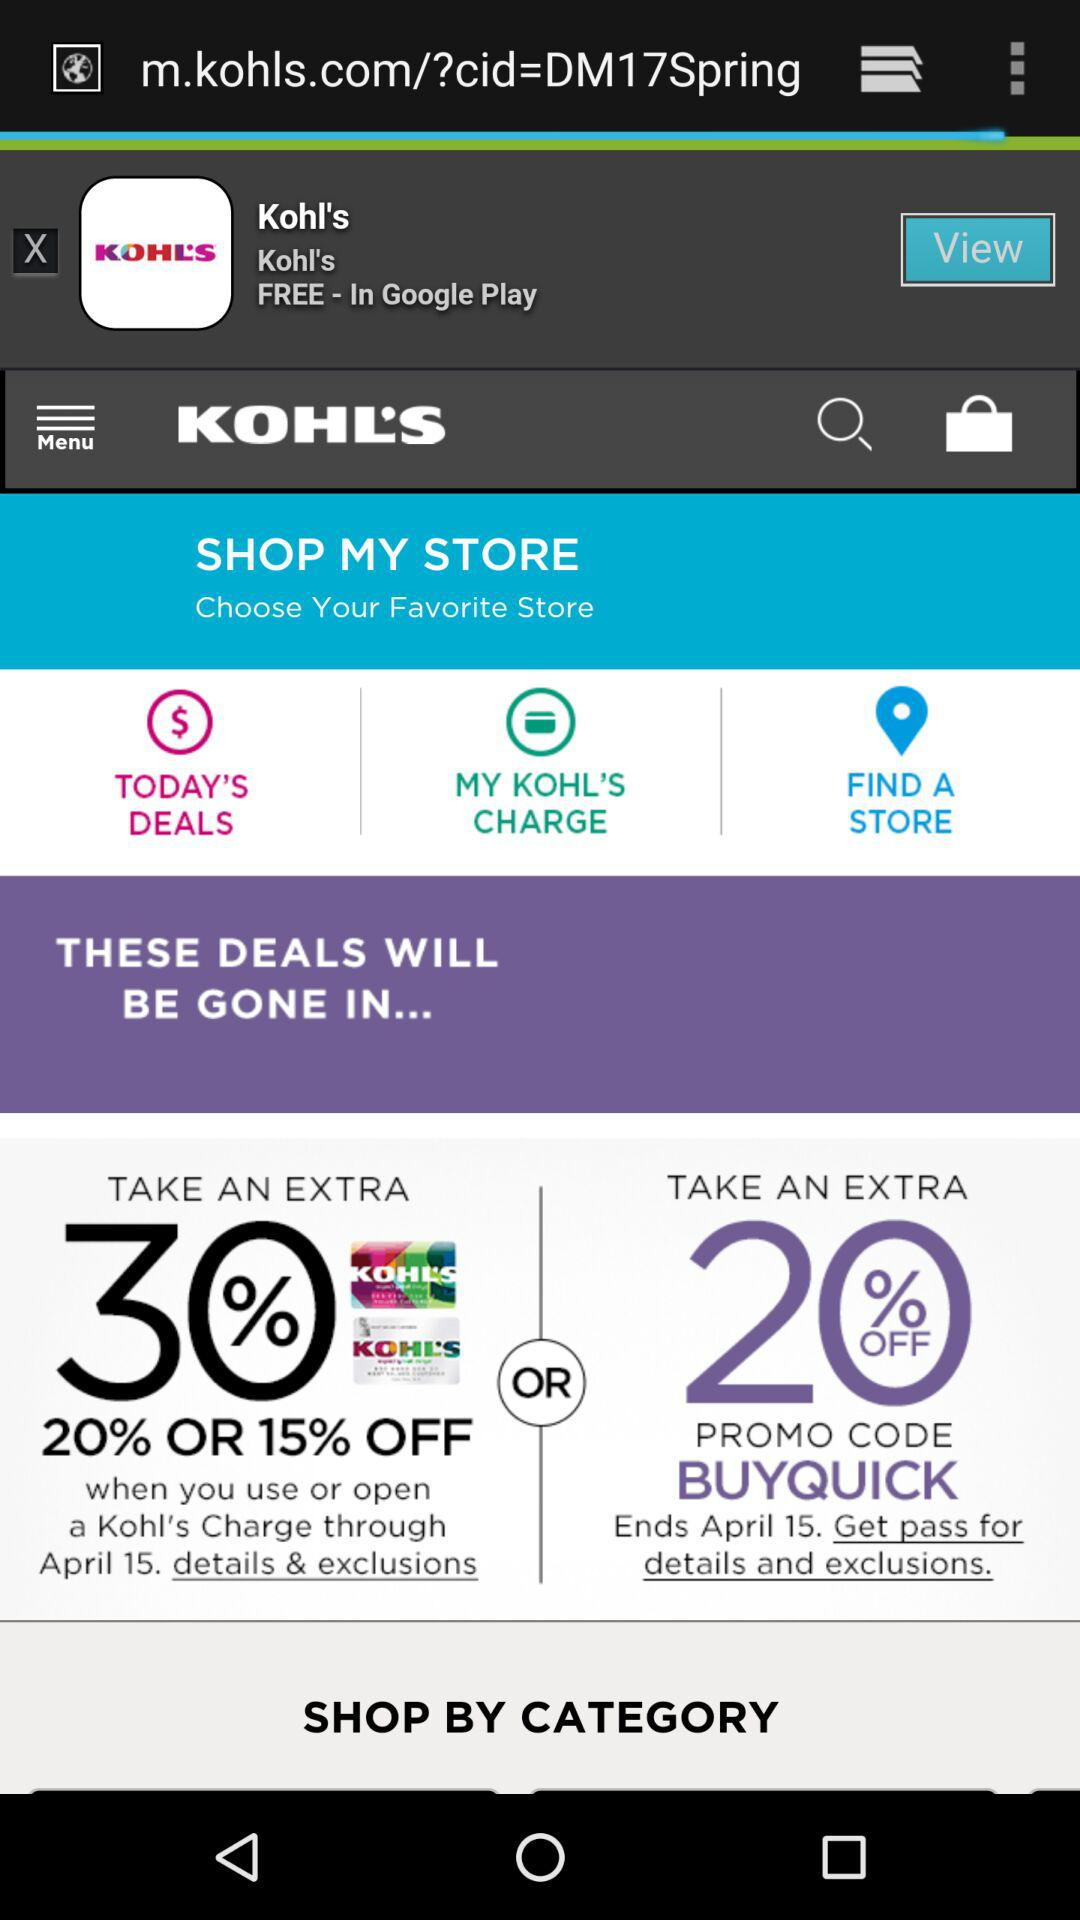What's the extra discount on using the promo code "BUYQUICK"? The extra discount on using the promo code "BUYQUICK" is 20 percent. 